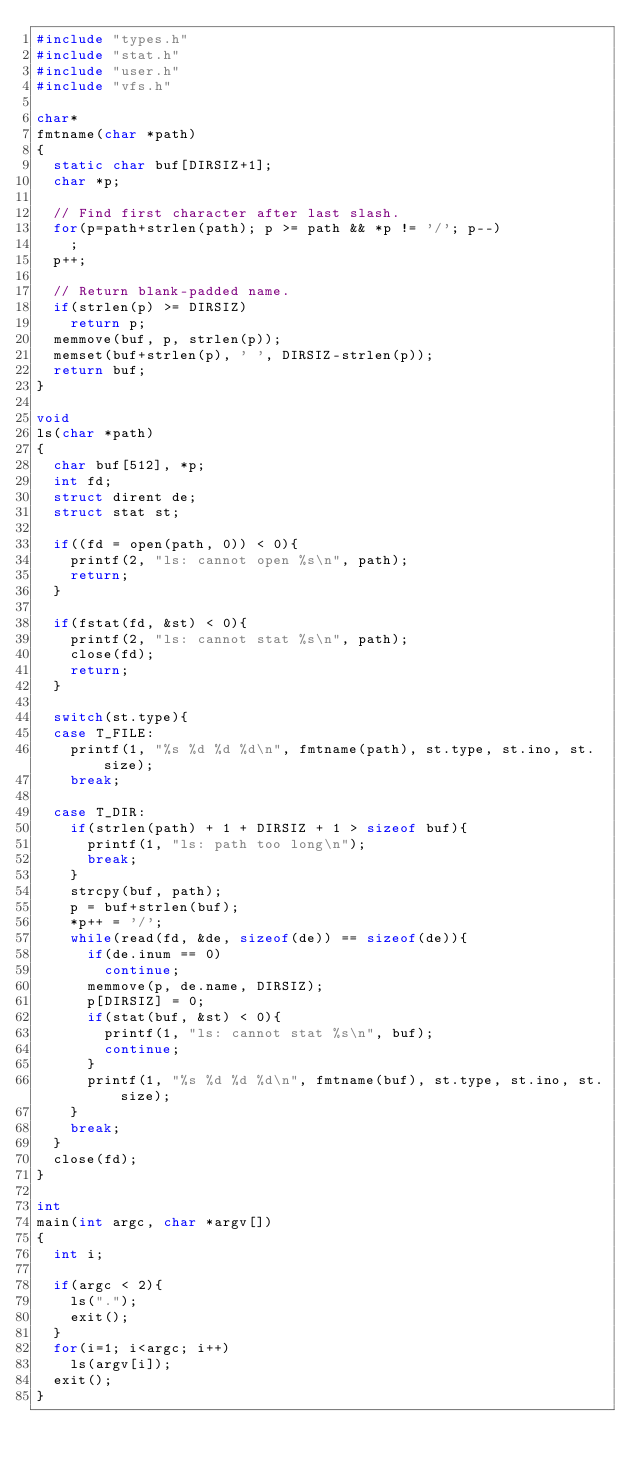<code> <loc_0><loc_0><loc_500><loc_500><_C_>#include "types.h"
#include "stat.h"
#include "user.h"
#include "vfs.h"

char*
fmtname(char *path)
{
  static char buf[DIRSIZ+1];
  char *p;
  
  // Find first character after last slash.
  for(p=path+strlen(path); p >= path && *p != '/'; p--)
    ;
  p++;
  
  // Return blank-padded name.
  if(strlen(p) >= DIRSIZ)
    return p;
  memmove(buf, p, strlen(p));
  memset(buf+strlen(p), ' ', DIRSIZ-strlen(p));
  return buf;
}

void
ls(char *path)
{
  char buf[512], *p;
  int fd;
  struct dirent de;
  struct stat st;
  
  if((fd = open(path, 0)) < 0){
    printf(2, "ls: cannot open %s\n", path);
    return;
  }
  
  if(fstat(fd, &st) < 0){
    printf(2, "ls: cannot stat %s\n", path);
    close(fd);
    return;
  }
  
  switch(st.type){
  case T_FILE:
    printf(1, "%s %d %d %d\n", fmtname(path), st.type, st.ino, st.size);
    break;
  
  case T_DIR:
    if(strlen(path) + 1 + DIRSIZ + 1 > sizeof buf){
      printf(1, "ls: path too long\n");
      break;
    }
    strcpy(buf, path);
    p = buf+strlen(buf);
    *p++ = '/';
    while(read(fd, &de, sizeof(de)) == sizeof(de)){
      if(de.inum == 0)
        continue;
      memmove(p, de.name, DIRSIZ);
      p[DIRSIZ] = 0;
      if(stat(buf, &st) < 0){
        printf(1, "ls: cannot stat %s\n", buf);
        continue;
      }
      printf(1, "%s %d %d %d\n", fmtname(buf), st.type, st.ino, st.size);
    }
    break;
  }
  close(fd);
}

int
main(int argc, char *argv[])
{
  int i;

  if(argc < 2){
    ls(".");
    exit();
  }
  for(i=1; i<argc; i++)
    ls(argv[i]);
  exit();
}
</code> 